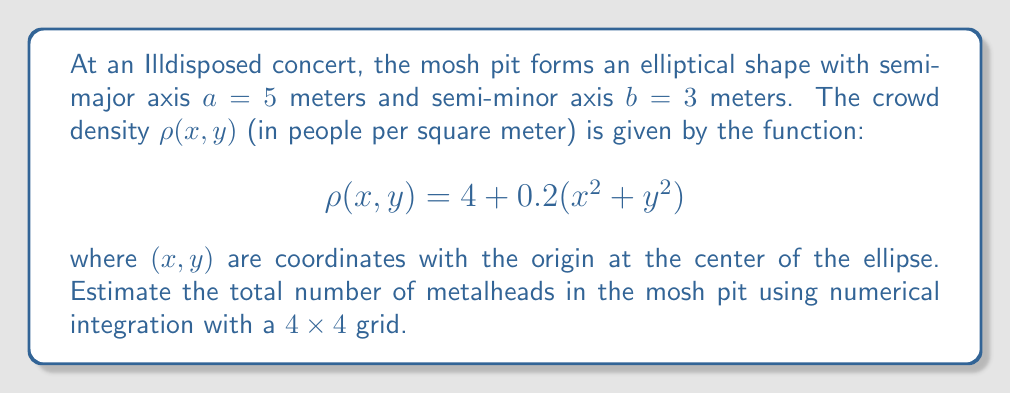Can you solve this math problem? To solve this problem, we'll use numerical integration with a 4x4 grid over the elliptical region. Here's the step-by-step process:

1) The equation of the ellipse is $\frac{x^2}{a^2} + \frac{y^2}{b^2} = 1$, where $a=5$ and $b=3$.

2) We'll use a rectangular grid that encompasses the ellipse. The grid will extend from $-5$ to $5$ in the x-direction and from $-3$ to $3$ in the y-direction.

3) Divide this region into a 4x4 grid. Each cell will have dimensions:
   $\Delta x = \frac{10}{4} = 2.5$ meters
   $\Delta y = \frac{6}{4} = 1.5$ meters

4) The coordinates of the cell centers are:
   x: $\{-3.75, -1.25, 1.25, 3.75\}$
   y: $\{-2.25, -0.75, 0.75, 2.25\}$

5) For each cell, we need to:
   a) Check if its center is inside the ellipse
   b) If yes, calculate $\rho(x,y)$ at the cell center
   c) Multiply $\rho(x,y)$ by the cell area $(\Delta x \cdot \Delta y = 3.75$ m²)

6) Let's calculate for each cell:

   | x    | y    | In ellipse? | $\rho(x,y)$     | People in cell |
   |------|------|-------------|-----------------|----------------|
   |-3.75 |-2.25 | Yes         | 6.5625          | 24.609375      |
   |-3.75 |-0.75 | Yes         | 5.8125          | 21.796875      |
   |-3.75 | 0.75 | Yes         | 5.8125          | 21.796875      |
   |-3.75 | 2.25 | Yes         | 6.5625          | 24.609375      |
   |-1.25 |-2.25 | Yes         | 5.3125          | 19.921875      |
   |-1.25 |-0.75 | Yes         | 4.5625          | 17.109375      |
   |-1.25 | 0.75 | Yes         | 4.5625          | 17.109375      |
   |-1.25 | 2.25 | Yes         | 5.3125          | 19.921875      |
   | 1.25 |-2.25 | Yes         | 5.3125          | 19.921875      |
   | 1.25 |-0.75 | Yes         | 4.5625          | 17.109375      |
   | 1.25 | 0.75 | Yes         | 4.5625          | 17.109375      |
   | 1.25 | 2.25 | Yes         | 5.3125          | 19.921875      |
   | 3.75 |-2.25 | Yes         | 6.5625          | 24.609375      |
   | 3.75 |-0.75 | Yes         | 5.8125          | 21.796875      |
   | 3.75 | 0.75 | Yes         | 5.8125          | 21.796875      |
   | 3.75 | 2.25 | Yes         | 6.5625          | 24.609375      |

7) Sum up all the "People in cell" values: 333.75

Therefore, our numerical integration estimates approximately 334 metalheads in the Illdisposed mosh pit.
Answer: 334 metalheads (rounded to the nearest whole number) 